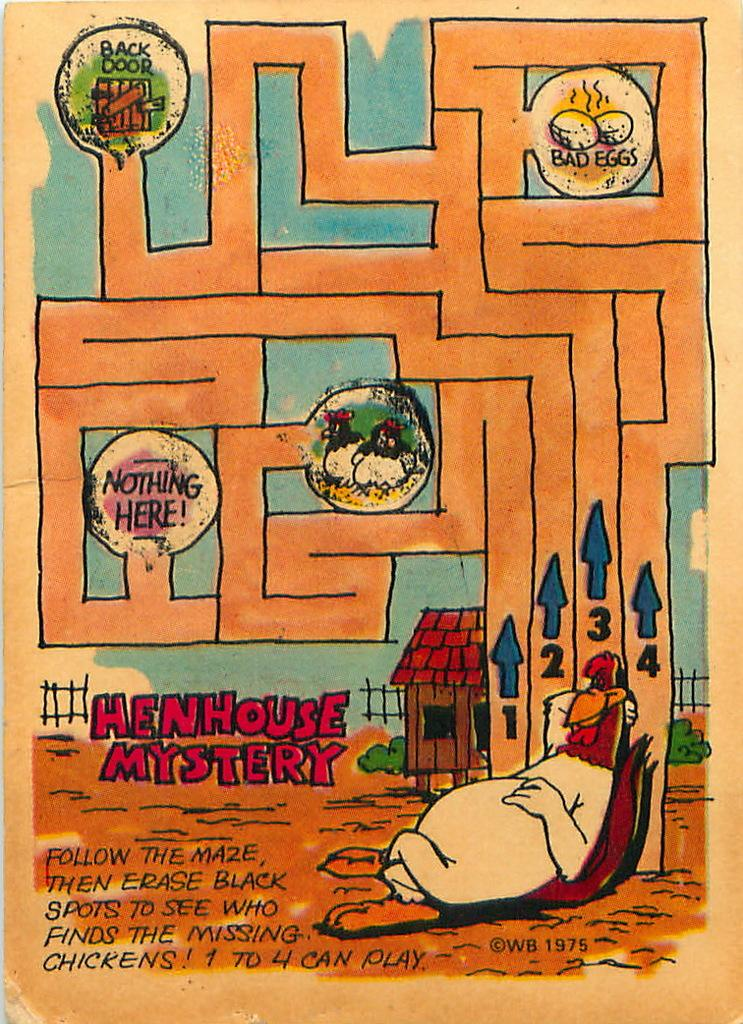<image>
Give a short and clear explanation of the subsequent image. A comic called Henhouse Mystery tells the reader to follow the maze 